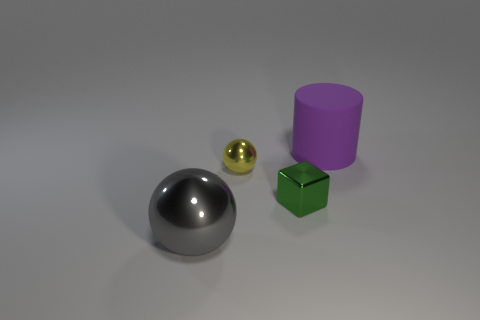Add 4 green blocks. How many objects exist? 8 Subtract all cubes. How many objects are left? 3 Add 1 tiny blocks. How many tiny blocks are left? 2 Add 1 tiny yellow metallic things. How many tiny yellow metallic things exist? 2 Subtract 0 green cylinders. How many objects are left? 4 Subtract all big yellow metallic things. Subtract all large gray objects. How many objects are left? 3 